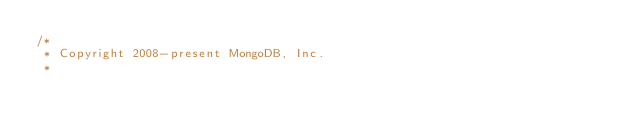Convert code to text. <code><loc_0><loc_0><loc_500><loc_500><_Scala_>/*
 * Copyright 2008-present MongoDB, Inc.
 *</code> 